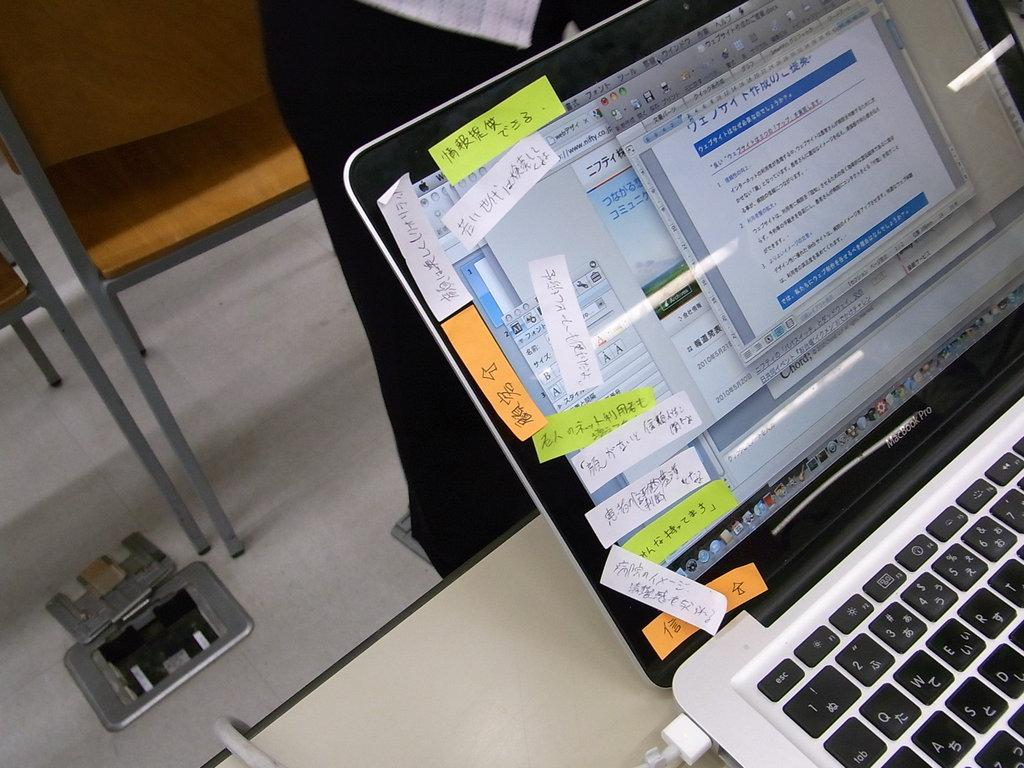<image>
Offer a succinct explanation of the picture presented. A laptop open and displaying a webpage that is in chinese writing. 